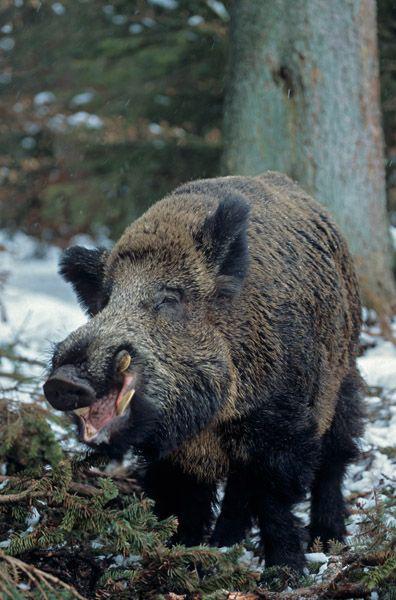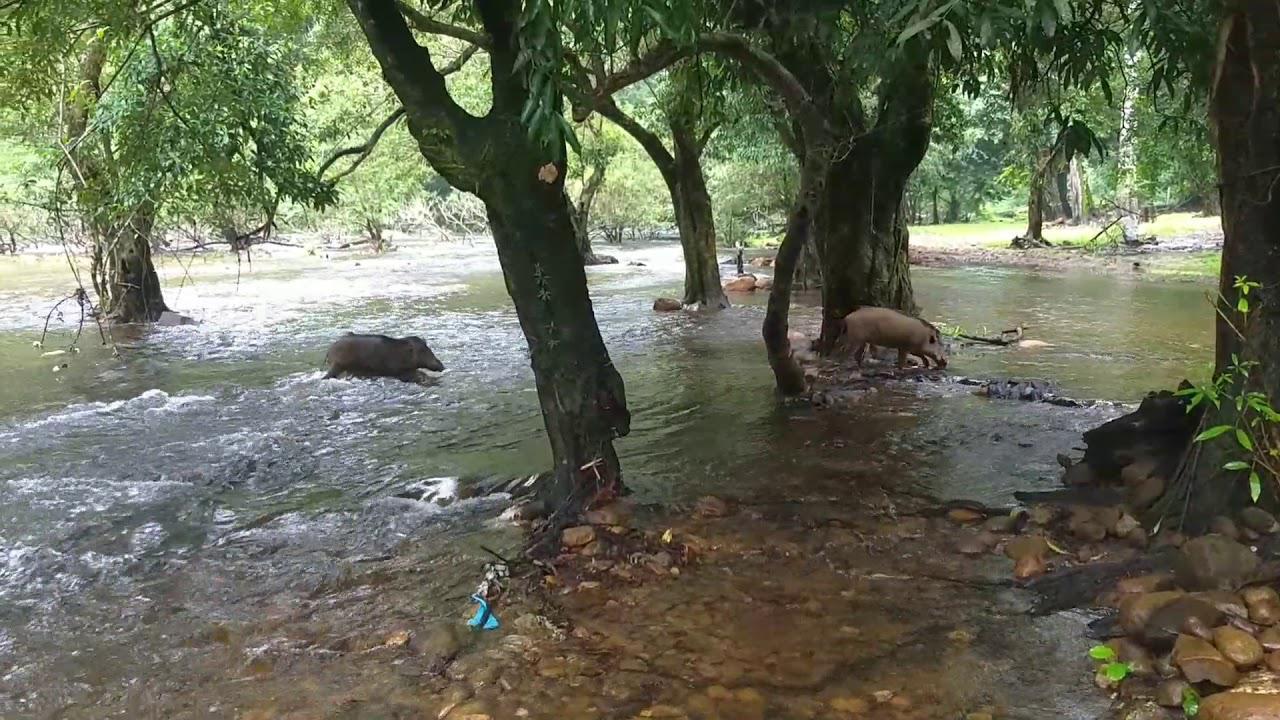The first image is the image on the left, the second image is the image on the right. Considering the images on both sides, is "One image shows a single forward-facing wild pig standing in an area that is not covered in water, and the other image shows at least one pig in water." valid? Answer yes or no. Yes. The first image is the image on the left, the second image is the image on the right. Analyze the images presented: Is the assertion "In at least one image there is a single boar facing right in the water next to the grassy bank." valid? Answer yes or no. No. 